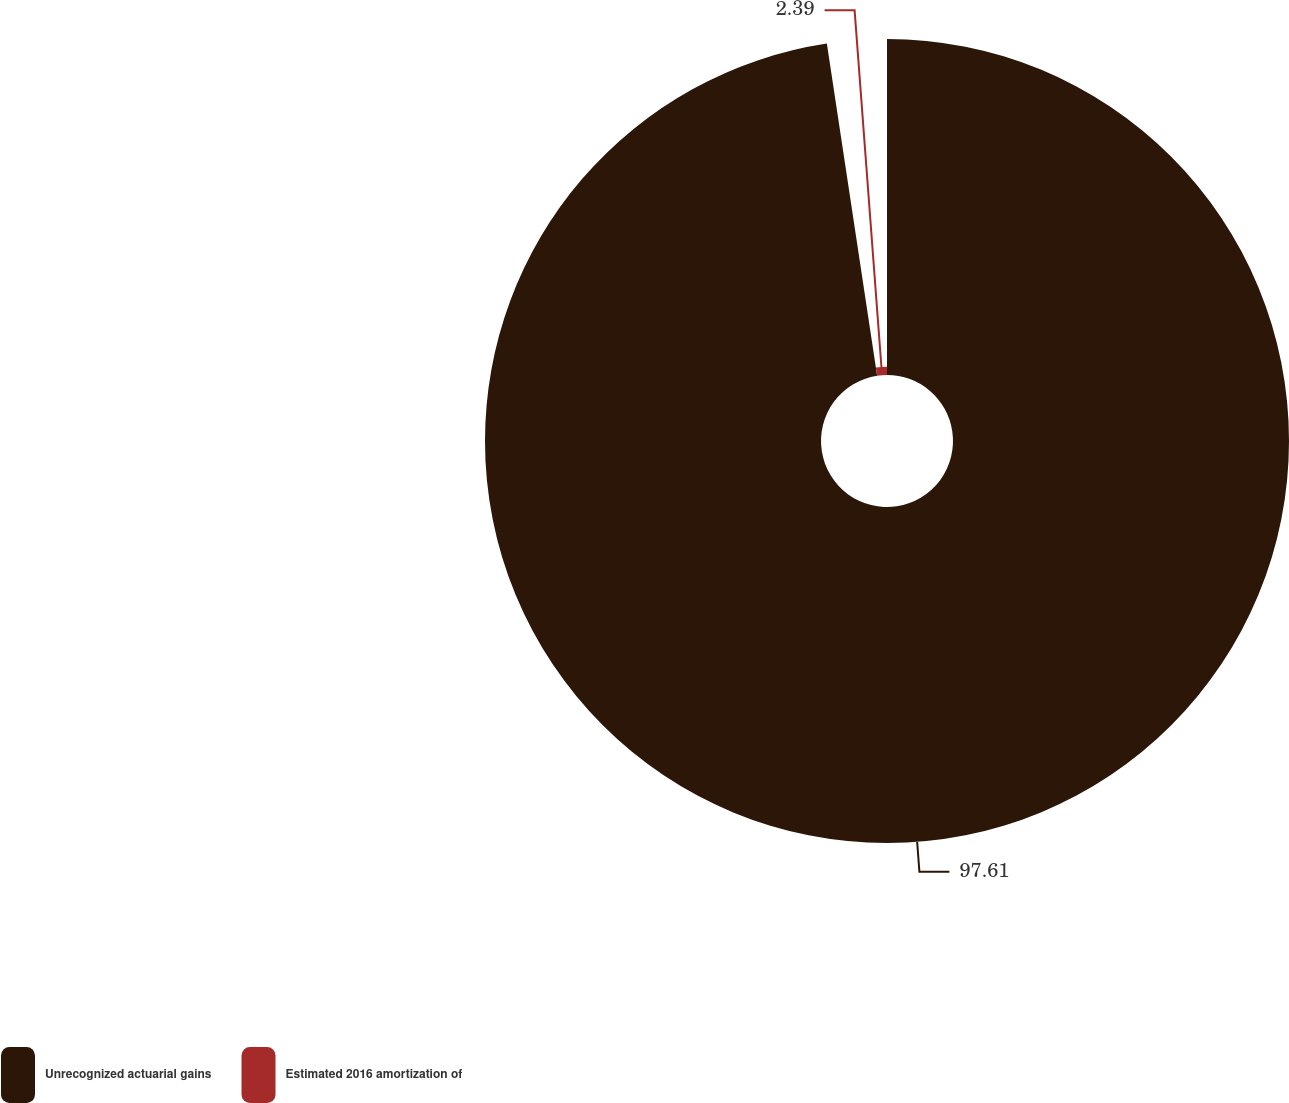<chart> <loc_0><loc_0><loc_500><loc_500><pie_chart><fcel>Unrecognized actuarial gains<fcel>Estimated 2016 amortization of<nl><fcel>97.61%<fcel>2.39%<nl></chart> 